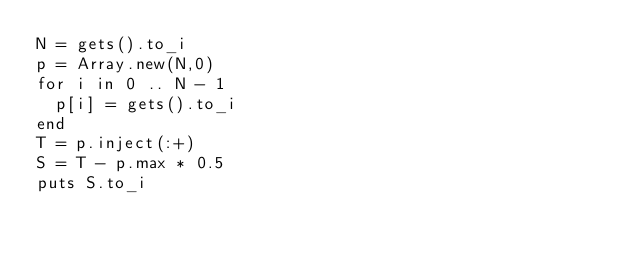<code> <loc_0><loc_0><loc_500><loc_500><_Ruby_>N = gets().to_i
p = Array.new(N,0)
for i in 0 .. N - 1
  p[i] = gets().to_i
end
T = p.inject(:+)
S = T - p.max * 0.5
puts S.to_i
</code> 